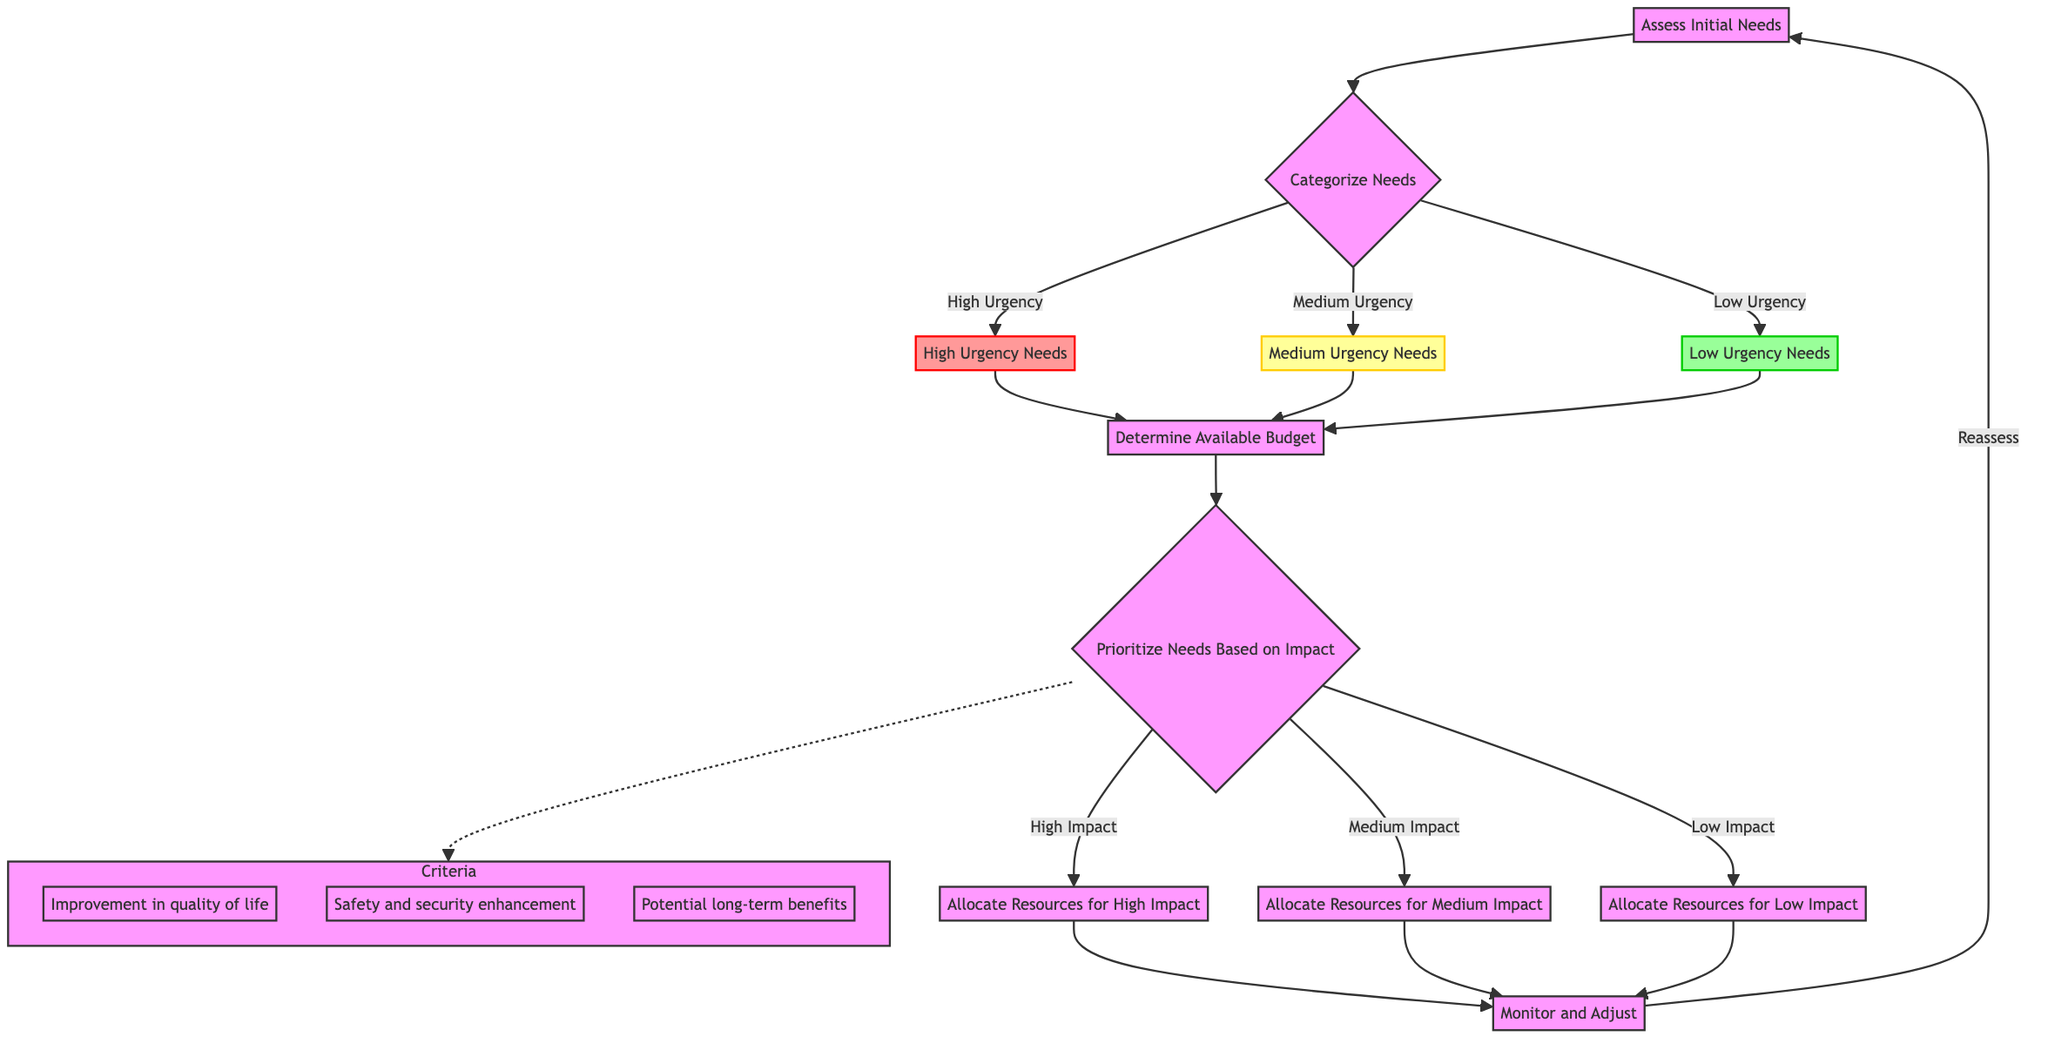What are the steps illustrated in the diagram? The diagram begins with "Assess Initial Needs," followed by "Categorize Needs by Urgency," then "Determine Available Budget," proceeds to "Prioritize Needs Based on Impact," leads to "Allocate Resources," and concludes with "Monitor and Adjust."
Answer: Assess Initial Needs, Categorize Needs by Urgency, Determine Available Budget, Prioritize Needs Based on Impact, Allocate Resources, Monitor and Adjust How many categories of urgency are there? The diagram presents three categories of urgency: High Urgency, Medium Urgency, and Low Urgency.
Answer: Three categories What follows after "Determine Available Budget"? After "Determine Available Budget," the next step is "Prioritize Needs Based on Impact."
Answer: Prioritize Needs Based on Impact Which step has the criteria for prioritization? The step "Prioritize Needs Based on Impact" includes the criteria for decision-making on resource allocation based on impact.
Answer: Prioritize Needs Based on Impact What actions are suggested under "Monitor and Adjust"? The actions include conducting follow-up assessments, reevaluating budget allocations periodically, and making necessary adjustments based on changing circumstances.
Answer: Conduct follow-up assessments, reevaluate budget allocations periodically, make necessary adjustments Which needs are addressed first when allocating resources? Resources are allocated first to the high-impact needs before medium and low-impact needs.
Answer: High-impact needs What categorizes a need as "High Urgency"? A need is categorized as "High Urgency" if it must be addressed within 24-48 hours.
Answer: Must be addressed within 24-48 hours How does the diagram classify an improvement in quality of life? Improvement in quality of life is one of the criteria stated under "Prioritize Needs Based on Impact," indicating its significance in decision-making.
Answer: One of the criteria for impact 